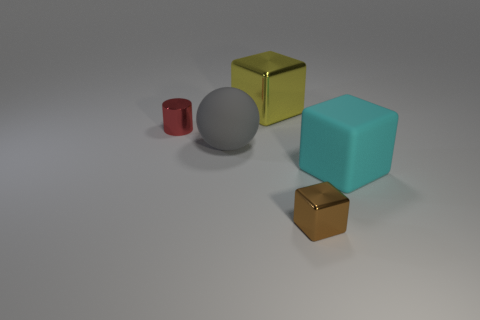Subtract all cylinders. How many objects are left? 4 Subtract 1 balls. How many balls are left? 0 Subtract all yellow cubes. Subtract all gray cylinders. How many cubes are left? 2 Subtract all gray balls. How many brown blocks are left? 1 Subtract all cyan shiny blocks. Subtract all gray matte balls. How many objects are left? 4 Add 1 yellow metallic objects. How many yellow metallic objects are left? 2 Add 2 small cylinders. How many small cylinders exist? 3 Add 4 large metallic cubes. How many objects exist? 9 Subtract all brown cubes. How many cubes are left? 2 Subtract all large cubes. How many cubes are left? 1 